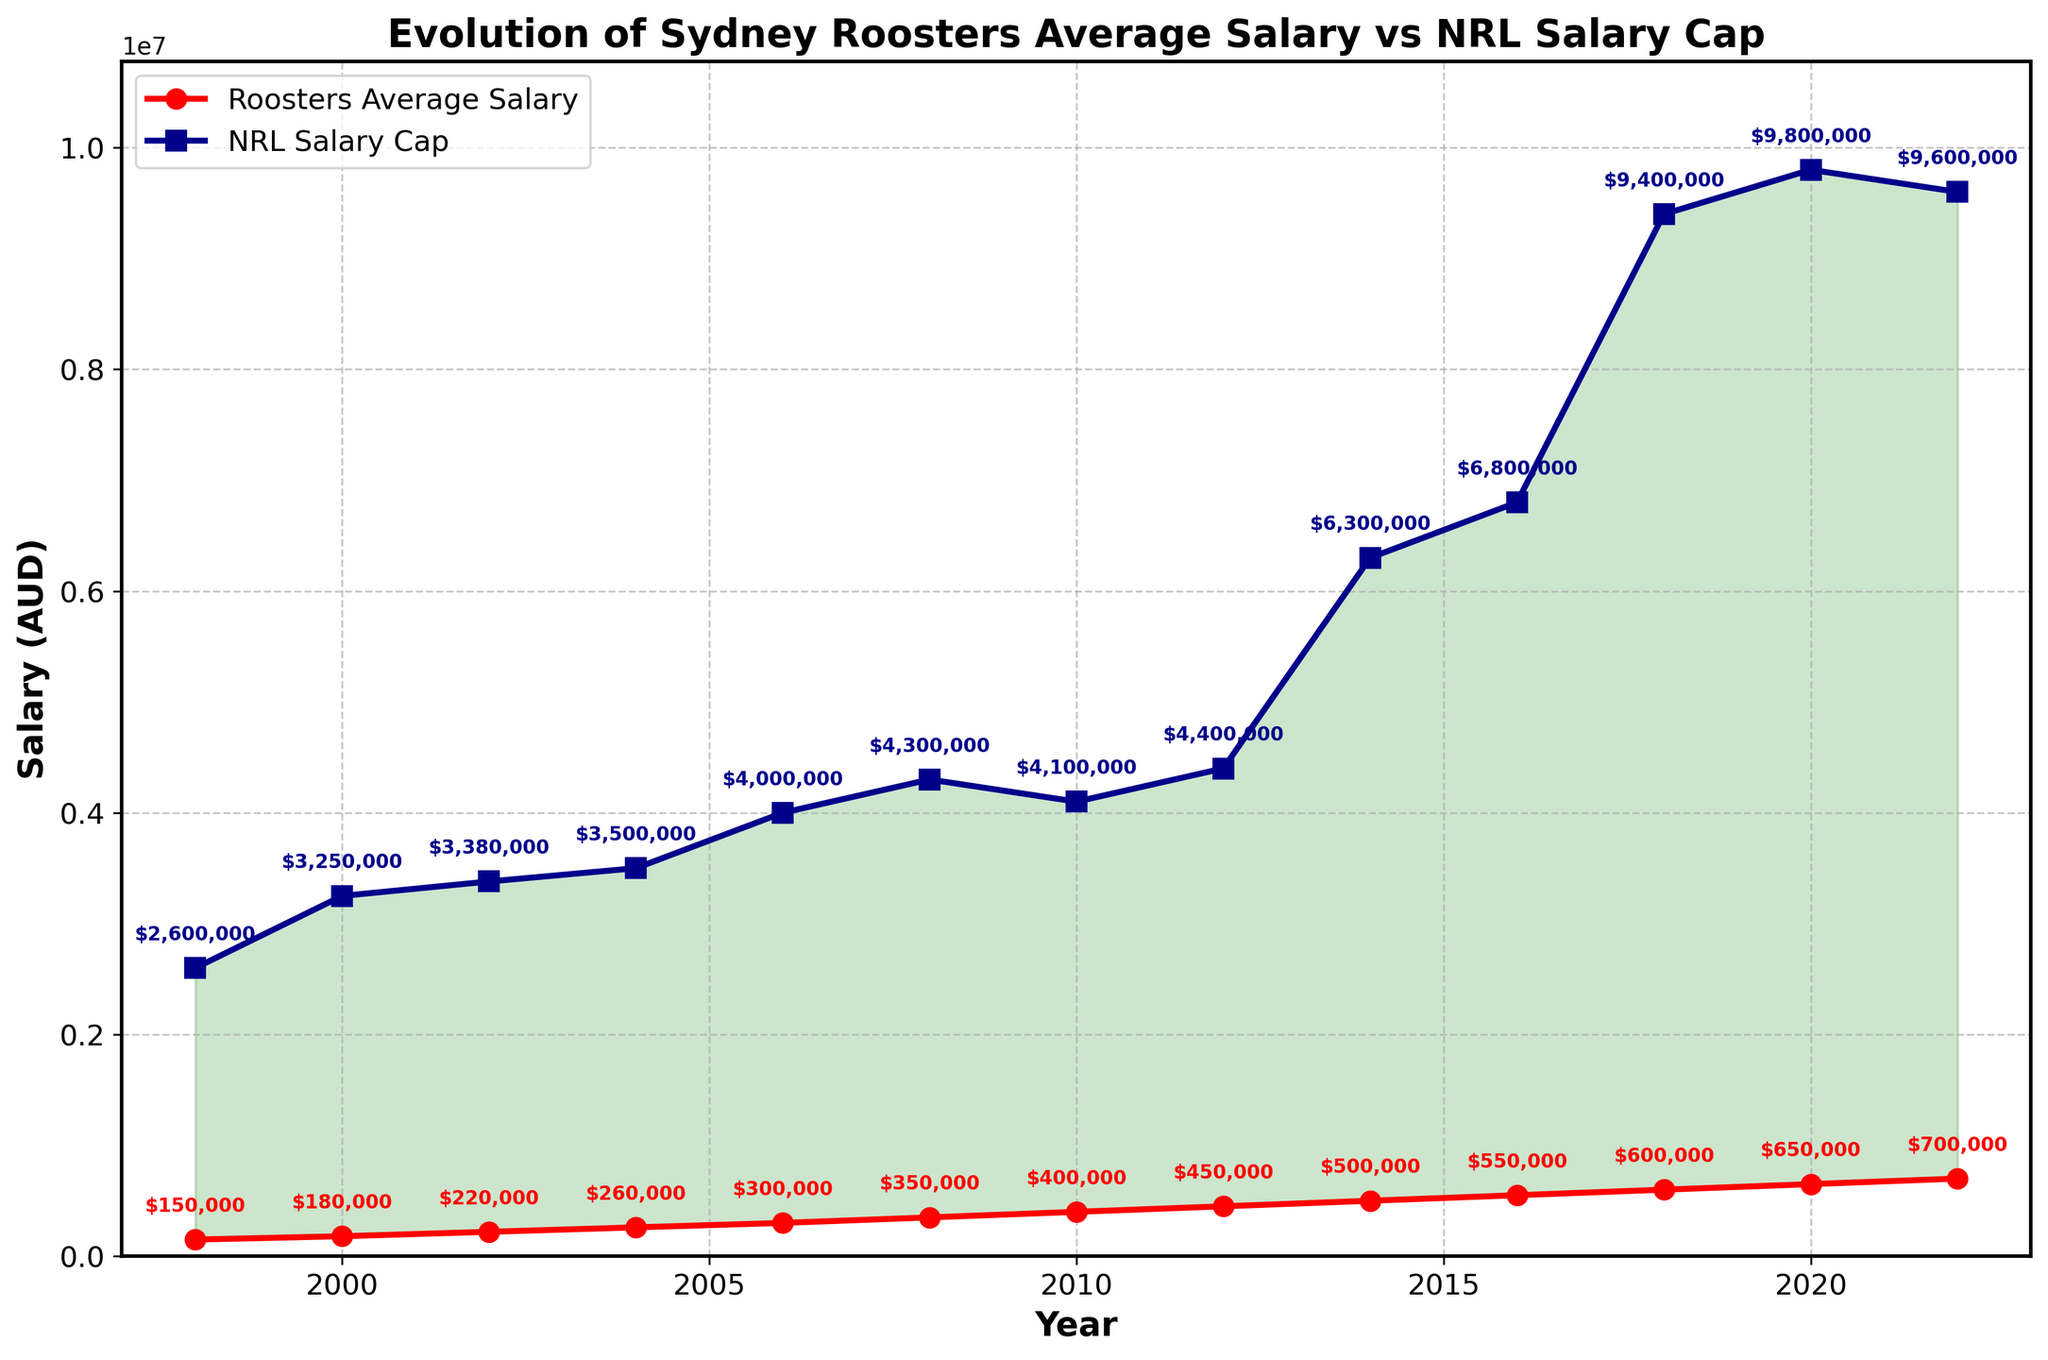What's the difference between the Sydney Roosters' average salary and the NRL salary cap in 2010? In 2010, the NRL salary cap is $4,100,000 and the Roosters' average salary is $400,000. Subtract the Roosters' average salary from the NRL salary cap to get the difference: $4,100,000 - $400,000 = $3,700,000.
Answer: $3,700,000 In which year did the Sydney Roosters' average salary first exceed $500,000? Looking at the line chart, the Sydney Roosters' average salary exceeds $500,000 for the first time in 2014.
Answer: 2014 By how much did the Roosters' average salary increase from 1998 to 2022? The Roosters' average salary in 1998 is $150,000 and in 2022 it is $700,000. Subtract the 1998 value from the 2022 value to find the increase: $700,000 - $150,000 = $550,000.
Answer: $550,000 Which had a higher percentage increase between 2012 and 2014: the Sydney Roosters' average salary or the NRL salary cap? The Roosters' average salary in 2012 is $450,000, increasing to $500,000 in 2014. The NRL salary cap in 2012 is $4,400,000 and increases to $6,300,000 in 2014. Calculate the percentage increase for each: For Roosters: (($500,000 - $450,000) / $450,000) * 100 = 11.1%. For NRL: (($6,300,000 - $4,400,000) / $4,400,000) * 100 = 43.2%. The NRL salary cap had a higher percentage increase.
Answer: NRL salary cap In 2008, by how much was the NRL salary cap greater than the Roosters' average salary? In 2008, the NRL salary cap is $4,300,000 and the Roosters' average salary is $350,000. Subtract the Roosters' average salary from the NRL salary cap: $4,300,000 - $350,000 = $3,950,000.
Answer: $3,950,000 During which years shown in the chart does the gap between the NRL salary cap and the Roosters' average salary visibly decrease? Comparing the gaps visually across the years, the gap decreases notably between 2010 and 2022. This is indicated by the lines converging closer, especially around 2014.
Answer: 2010-2022 What is the visual indicator used to show the space between the NRL salary cap and the Roosters' average salary? The space between the NRL salary cap and the Roosters' average salary is visually indicated by the shaded green area between the two lines in the chart.
Answer: Shaded green area By what absolute amount did the NRL salary cap grow between 2016 and 2018? The NRL salary cap in 2016 is $6,800,000 and in 2018 it is $9,400,000. Subtract the 2016 value from the 2018 value to find the absolute growth: $9,400,000 - $6,800,000 = $2,600,000.
Answer: $2,600,000 Which year shows the steepest increase in the Sydney Roosters' average salary? Based on the line chart, the steepest increase in the Roosters' average salary occurs between 2016 and 2018, where the slope of the line is steepest.
Answer: Between 2016 and 2018 